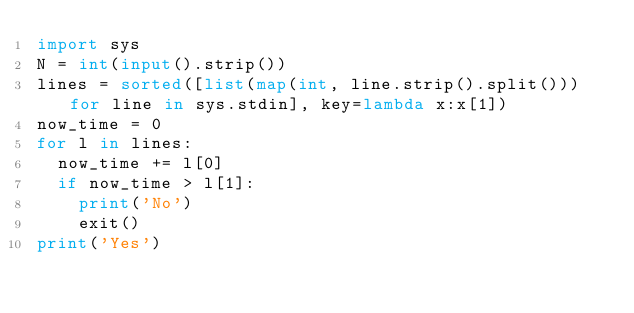Convert code to text. <code><loc_0><loc_0><loc_500><loc_500><_Python_>import sys
N = int(input().strip())
lines = sorted([list(map(int, line.strip().split())) for line in sys.stdin], key=lambda x:x[1])
now_time = 0
for l in lines:
  now_time += l[0]
  if now_time > l[1]:
    print('No')
    exit()
print('Yes')
</code> 